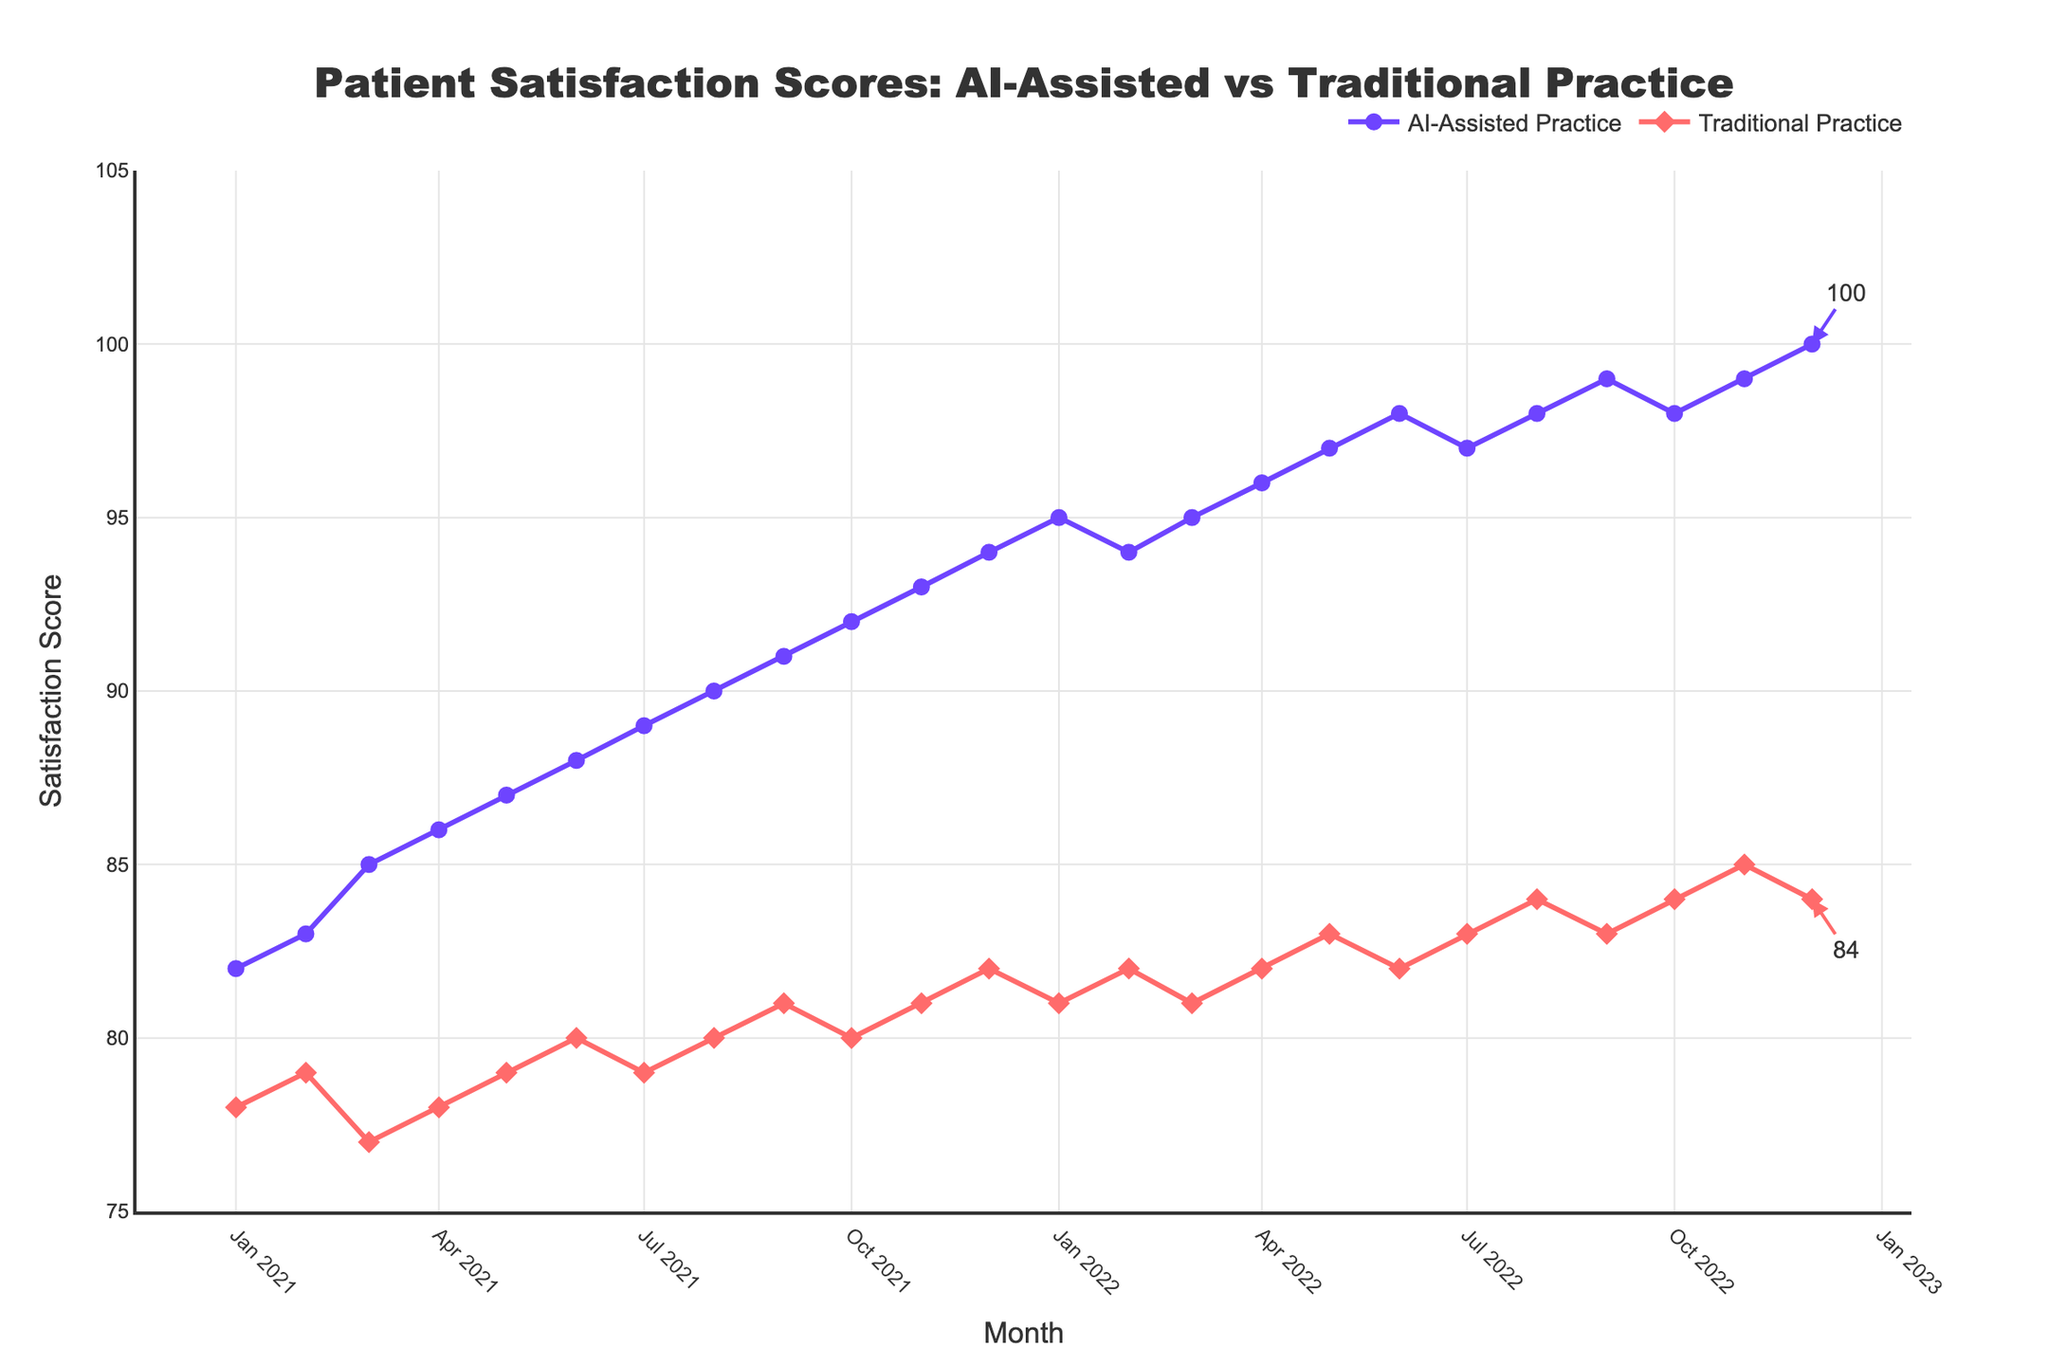What is the satisfaction score for AI-assisted practice in January 2021? The figure shows the satisfaction scores for every month. For January 2021, the score for AI-assisted practice is explicitly labeled.
Answer: 82 What is the difference in satisfaction scores between AI-assisted and traditional practice in December 2022? To find the difference, look at the scores for December 2022. AI-assisted practice is at 100, and traditional practice is at 84. Subtract the latter from the former.
Answer: 16 Which practice showed a higher satisfaction score in November 2021? Compare the scores for AI-assisted and traditional practices in November 2021. AI-assisted practice has a score of 93, and traditional practice has a score of 81.
Answer: AI-assisted practice By how many points did the AI-assisted practice’s satisfaction score increase from January 2021 to December 2022? The satisfaction score for AI-assisted practice was 82 in January 2021 and 100 in December 2022. The increase is calculated by subtracting 82 from 100.
Answer: 18 What is the average satisfaction score for traditional practice over the two years? Sum all monthly scores for traditional practice and divide by the number of months (24). Sum = (78 + 79 + 77 + ... + 84). Calculate the average of these numbers.
Answer: 81 In which month did traditional practice see its highest satisfaction score, and what was the score? Inspect the plot to find the peak value for the traditional practice line and note the corresponding month. The highest point is in November 2022 at 85.
Answer: November 2022, 85 Is there a month where both practices have the same satisfaction score? Compare the scores for both practices for each month. All months show different scores between the two practices.
Answer: No What is the trend in satisfaction scores for AI-assisted practice from January 2022 to April 2022? Observe the line for AI-assisted practice from January to April 2022. The scores increase from 95 to 96 over this period.
Answer: Increasing By how much did the traditional practice's satisfaction score increase in October 2021 compared to the previous month? Check the scores for September 2021 (81) and October 2021 (80). Subtract the September score from the October score (80 - 81 = -1). There is no increase, actually, the score decreased.
Answer: Decreased by 1 Which practice had a more consistent increase in satisfaction scores throughout the two years? Examine the overall trends for both lines. The AI-assisted practice line shows a consistent increase, while the traditional practice line has more fluctuations.
Answer: AI-assisted practice 